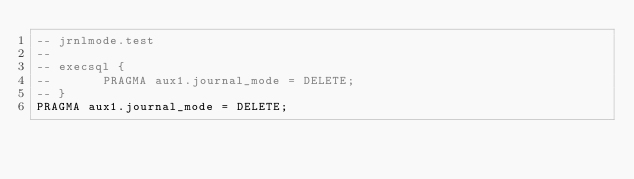Convert code to text. <code><loc_0><loc_0><loc_500><loc_500><_SQL_>-- jrnlmode.test
-- 
-- execsql {
--       PRAGMA aux1.journal_mode = DELETE;
-- }
PRAGMA aux1.journal_mode = DELETE;</code> 